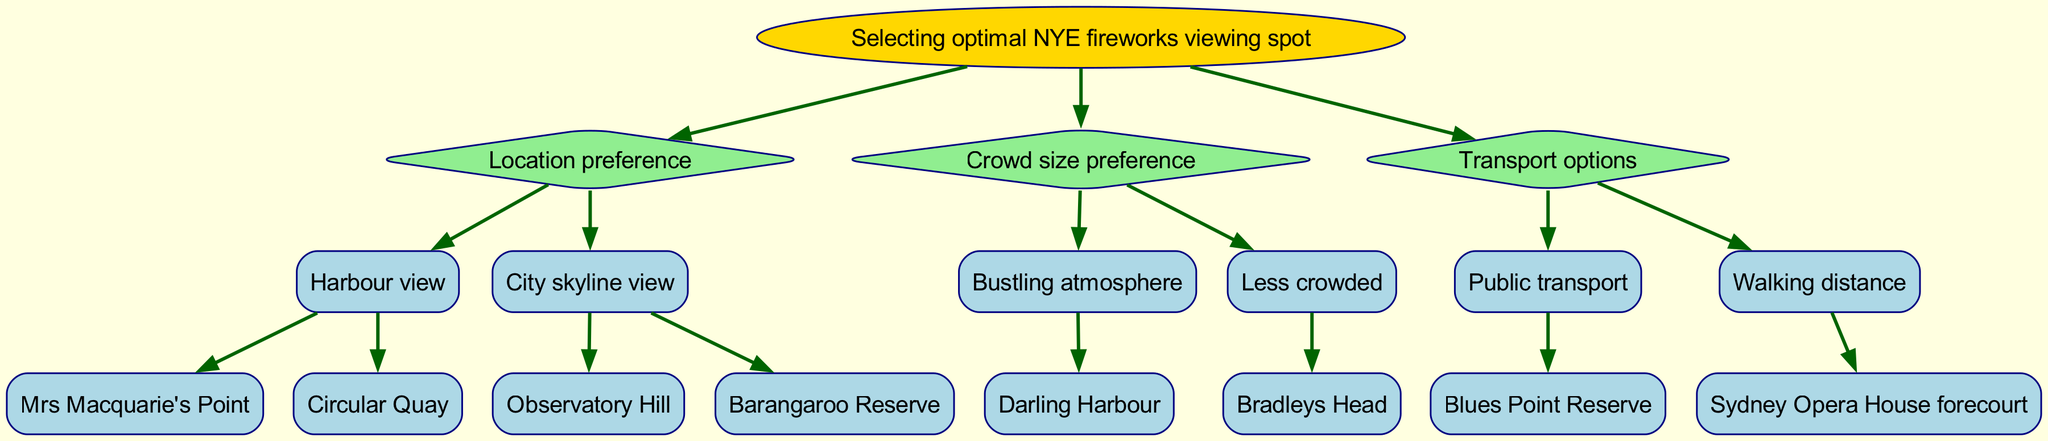What is the root node of the decision tree? The root node represents the main decision point of the diagram, which is "Selecting optimal NYE fireworks viewing spot."
Answer: Selecting optimal NYE fireworks viewing spot How many main branches does the decision tree have? There are three main branches emerging from the root node: "Location preference", "Crowd size preference", and "Transport options".
Answer: 3 What location is recommended for a bustling atmosphere? The diagram indicates that "Darling Harbour" is the only option that fits the description of a bustling atmosphere under the "Crowd size preference" branch.
Answer: Darling Harbour Which node provides a public transport recommendation? Examining the "Transport options" branch, "Blues Point Reserve" is the node that corresponds with public transport suggestions.
Answer: Blues Point Reserve If someone prefers a less crowded area, which location should they choose? "Bradleys Head" is the option listed under the "Less crowded" section of the "Crowd size preference" branch, making it the recommended location for someone looking for less crowding.
Answer: Bradleys Head What are the two options for a harbour view? The two options listed under the "Harbour view" node are "Mrs Macquarie's Point" and "Circular Quay".
Answer: Mrs Macquarie's Point and Circular Quay Which location is within walking distance of the fireworks? Under the "Transport options" branch, the diagram states that "Sydney Opera House forecourt" is the location that can be reached within walking distance, making it the answer to this question.
Answer: Sydney Opera House forecourt What type of view does "Observatory Hill" provide? "Observatory Hill" is categorized under the "City skyline view" node, indicating that it provides a view of the city skyline rather than the harbour.
Answer: City skyline view 